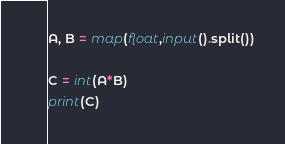Convert code to text. <code><loc_0><loc_0><loc_500><loc_500><_Python_>A, B = map(float,input().split())

C = int(A*B)
print(C)</code> 